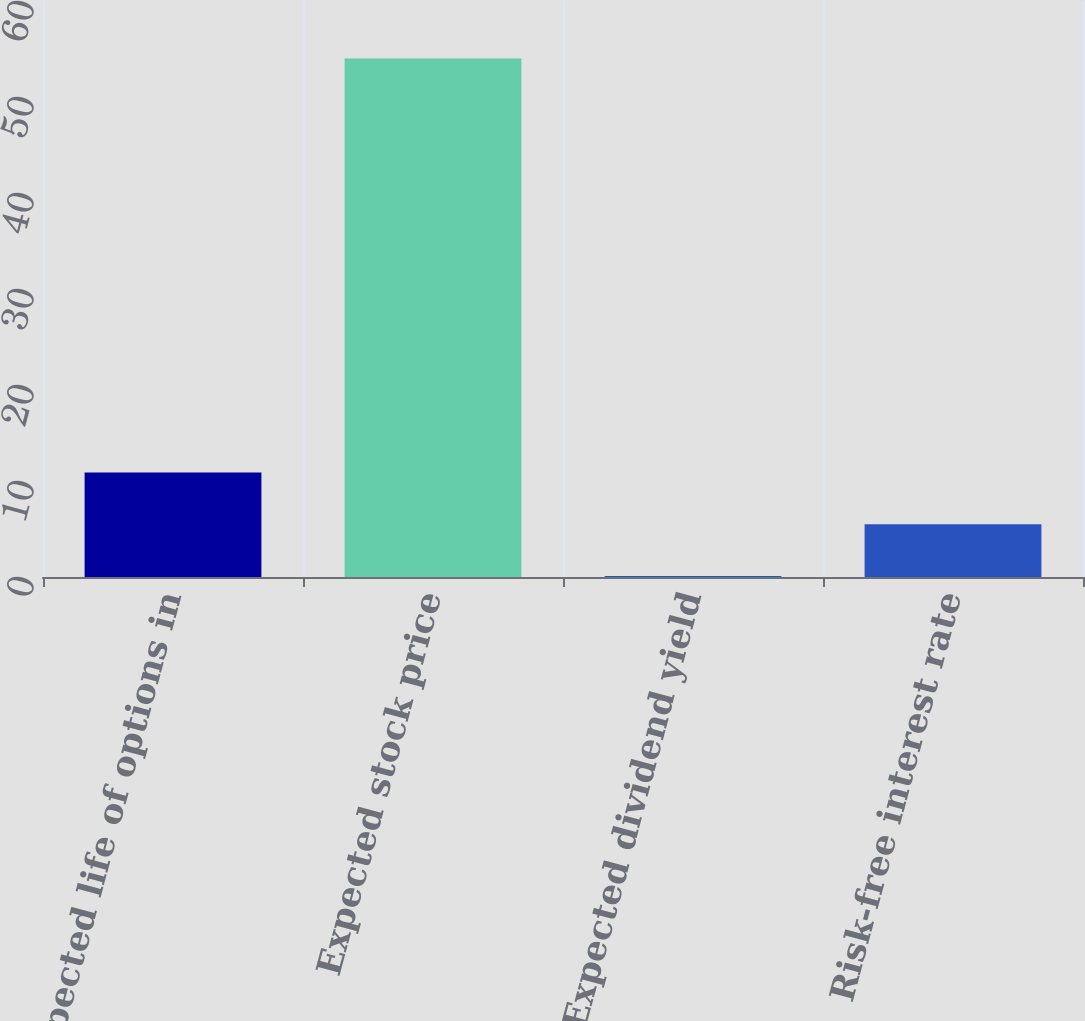Convert chart. <chart><loc_0><loc_0><loc_500><loc_500><bar_chart><fcel>Expected life of options in<fcel>Expected stock price<fcel>Expected dividend yield<fcel>Risk-free interest rate<nl><fcel>10.88<fcel>54<fcel>0.1<fcel>5.49<nl></chart> 